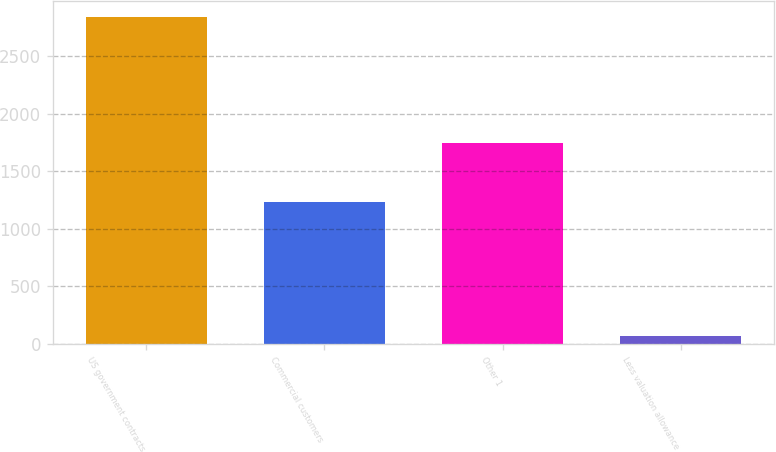<chart> <loc_0><loc_0><loc_500><loc_500><bar_chart><fcel>US government contracts<fcel>Commercial customers<fcel>Other 1<fcel>Less valuation allowance<nl><fcel>2838<fcel>1232<fcel>1742<fcel>72<nl></chart> 